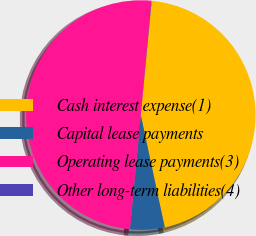<chart> <loc_0><loc_0><loc_500><loc_500><pie_chart><fcel>Cash interest expense(1)<fcel>Capital lease payments<fcel>Operating lease payments(3)<fcel>Other long-term liabilities(4)<nl><fcel>45.15%<fcel>4.85%<fcel>49.96%<fcel>0.04%<nl></chart> 